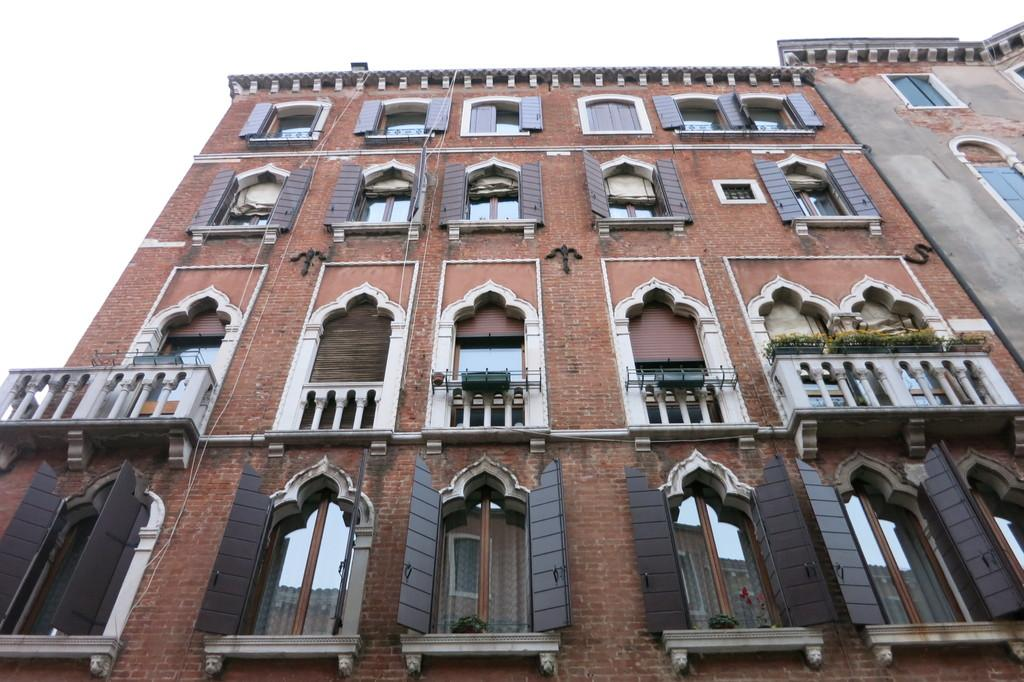What type of structures are visible in the image? There are buildings with windows in the image. What other elements can be seen in the image besides the buildings? There are plants in the image. What color is the background of the image? The background of the image is white. Are there any boats visible in the image? No, there are no boats present in the image. Can you see anyone swimming in the image? No, there is no swimming activity depicted in the image. 